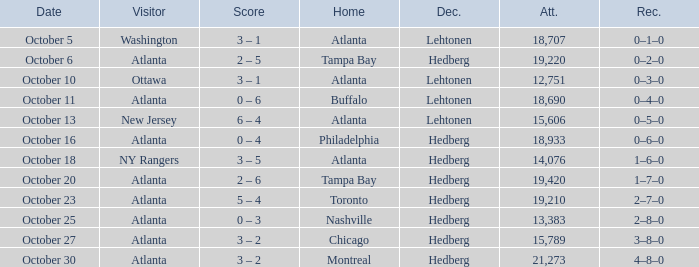What was the record on the game that was played on october 27? 3–8–0. 